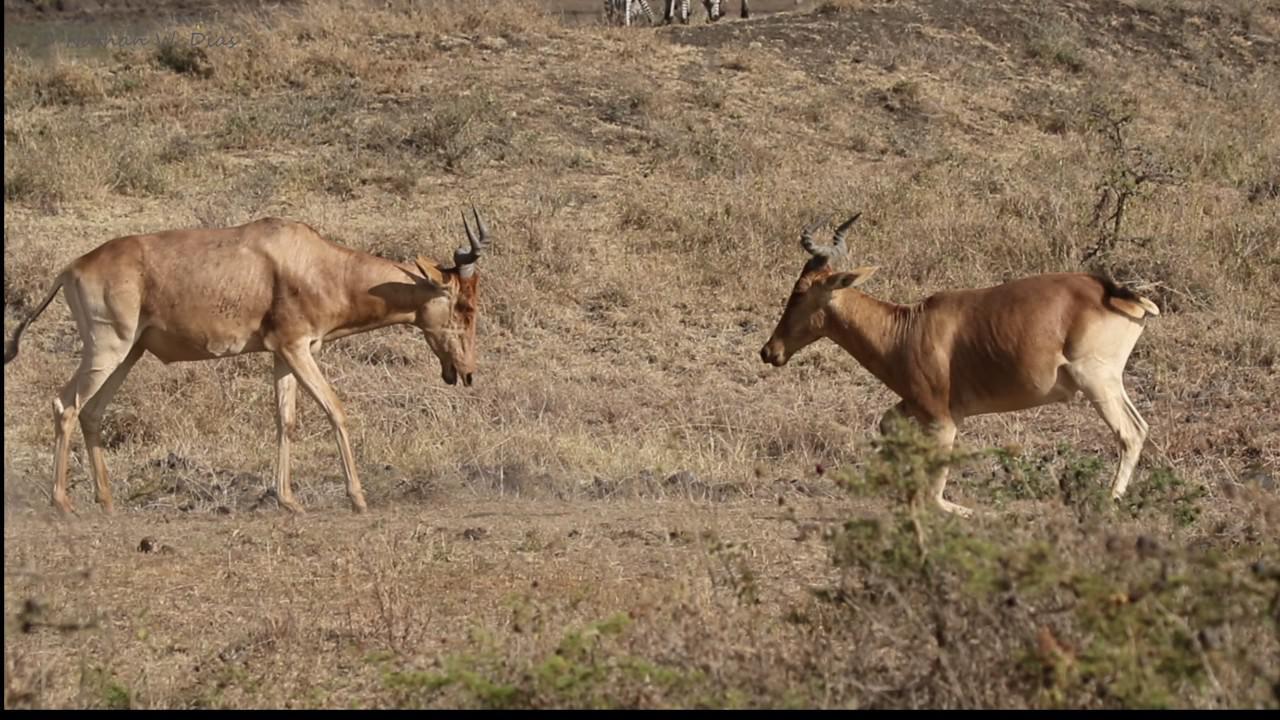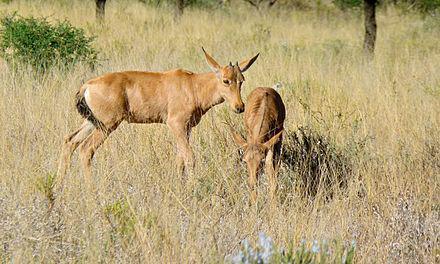The first image is the image on the left, the second image is the image on the right. For the images shown, is this caption "There is an animal looks straight at the camera" true? Answer yes or no. No. The first image is the image on the left, the second image is the image on the right. Analyze the images presented: Is the assertion "An image shows exactly two horned animals, which are facing each other." valid? Answer yes or no. Yes. 